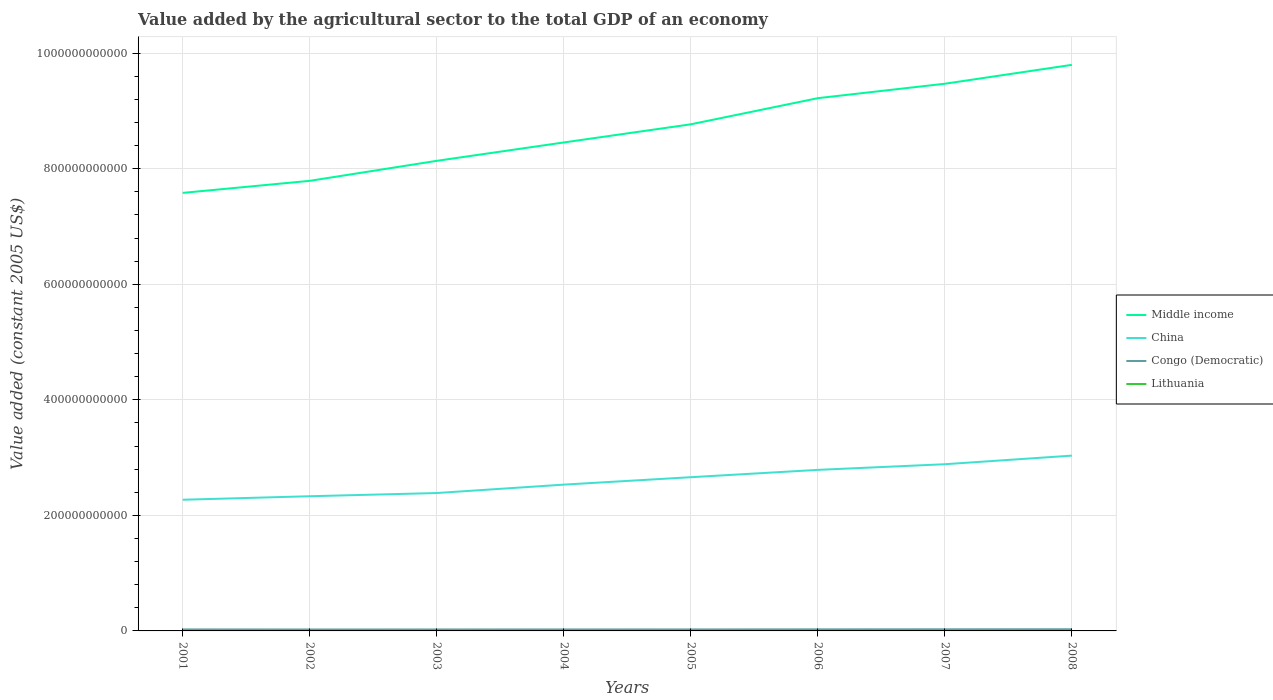Across all years, what is the maximum value added by the agricultural sector in Middle income?
Keep it short and to the point. 7.58e+11. What is the total value added by the agricultural sector in China in the graph?
Make the answer very short. -2.25e+1. What is the difference between the highest and the second highest value added by the agricultural sector in Congo (Democratic)?
Your response must be concise. 3.68e+08. Is the value added by the agricultural sector in Lithuania strictly greater than the value added by the agricultural sector in China over the years?
Give a very brief answer. Yes. What is the difference between two consecutive major ticks on the Y-axis?
Offer a terse response. 2.00e+11. Does the graph contain any zero values?
Ensure brevity in your answer.  No. Where does the legend appear in the graph?
Offer a very short reply. Center right. How are the legend labels stacked?
Offer a terse response. Vertical. What is the title of the graph?
Provide a succinct answer. Value added by the agricultural sector to the total GDP of an economy. Does "Lower middle income" appear as one of the legend labels in the graph?
Offer a terse response. No. What is the label or title of the X-axis?
Offer a terse response. Years. What is the label or title of the Y-axis?
Offer a very short reply. Value added (constant 2005 US$). What is the Value added (constant 2005 US$) of Middle income in 2001?
Your response must be concise. 7.58e+11. What is the Value added (constant 2005 US$) in China in 2001?
Offer a very short reply. 2.27e+11. What is the Value added (constant 2005 US$) of Congo (Democratic) in 2001?
Give a very brief answer. 2.61e+09. What is the Value added (constant 2005 US$) of Lithuania in 2001?
Provide a succinct answer. 1.03e+09. What is the Value added (constant 2005 US$) of Middle income in 2002?
Provide a succinct answer. 7.79e+11. What is the Value added (constant 2005 US$) of China in 2002?
Your response must be concise. 2.33e+11. What is the Value added (constant 2005 US$) in Congo (Democratic) in 2002?
Your response must be concise. 2.51e+09. What is the Value added (constant 2005 US$) of Lithuania in 2002?
Make the answer very short. 1.09e+09. What is the Value added (constant 2005 US$) in Middle income in 2003?
Give a very brief answer. 8.14e+11. What is the Value added (constant 2005 US$) in China in 2003?
Keep it short and to the point. 2.39e+11. What is the Value added (constant 2005 US$) of Congo (Democratic) in 2003?
Your response must be concise. 2.53e+09. What is the Value added (constant 2005 US$) of Lithuania in 2003?
Offer a very short reply. 1.15e+09. What is the Value added (constant 2005 US$) of Middle income in 2004?
Offer a very short reply. 8.46e+11. What is the Value added (constant 2005 US$) of China in 2004?
Ensure brevity in your answer.  2.53e+11. What is the Value added (constant 2005 US$) of Congo (Democratic) in 2004?
Keep it short and to the point. 2.57e+09. What is the Value added (constant 2005 US$) in Lithuania in 2004?
Ensure brevity in your answer.  1.11e+09. What is the Value added (constant 2005 US$) of Middle income in 2005?
Keep it short and to the point. 8.77e+11. What is the Value added (constant 2005 US$) in China in 2005?
Offer a terse response. 2.66e+11. What is the Value added (constant 2005 US$) of Congo (Democratic) in 2005?
Offer a very short reply. 2.58e+09. What is the Value added (constant 2005 US$) in Lithuania in 2005?
Provide a short and direct response. 1.13e+09. What is the Value added (constant 2005 US$) in Middle income in 2006?
Give a very brief answer. 9.22e+11. What is the Value added (constant 2005 US$) in China in 2006?
Ensure brevity in your answer.  2.79e+11. What is the Value added (constant 2005 US$) in Congo (Democratic) in 2006?
Keep it short and to the point. 2.73e+09. What is the Value added (constant 2005 US$) of Lithuania in 2006?
Keep it short and to the point. 1.01e+09. What is the Value added (constant 2005 US$) in Middle income in 2007?
Offer a very short reply. 9.47e+11. What is the Value added (constant 2005 US$) in China in 2007?
Offer a terse response. 2.89e+11. What is the Value added (constant 2005 US$) in Congo (Democratic) in 2007?
Ensure brevity in your answer.  2.80e+09. What is the Value added (constant 2005 US$) of Lithuania in 2007?
Ensure brevity in your answer.  1.13e+09. What is the Value added (constant 2005 US$) in Middle income in 2008?
Your answer should be very brief. 9.80e+11. What is the Value added (constant 2005 US$) of China in 2008?
Your answer should be very brief. 3.03e+11. What is the Value added (constant 2005 US$) in Congo (Democratic) in 2008?
Provide a short and direct response. 2.88e+09. What is the Value added (constant 2005 US$) of Lithuania in 2008?
Your answer should be compact. 1.16e+09. Across all years, what is the maximum Value added (constant 2005 US$) in Middle income?
Your answer should be very brief. 9.80e+11. Across all years, what is the maximum Value added (constant 2005 US$) in China?
Your answer should be very brief. 3.03e+11. Across all years, what is the maximum Value added (constant 2005 US$) of Congo (Democratic)?
Ensure brevity in your answer.  2.88e+09. Across all years, what is the maximum Value added (constant 2005 US$) of Lithuania?
Provide a short and direct response. 1.16e+09. Across all years, what is the minimum Value added (constant 2005 US$) of Middle income?
Offer a very short reply. 7.58e+11. Across all years, what is the minimum Value added (constant 2005 US$) of China?
Give a very brief answer. 2.27e+11. Across all years, what is the minimum Value added (constant 2005 US$) in Congo (Democratic)?
Your response must be concise. 2.51e+09. Across all years, what is the minimum Value added (constant 2005 US$) in Lithuania?
Offer a very short reply. 1.01e+09. What is the total Value added (constant 2005 US$) of Middle income in the graph?
Keep it short and to the point. 6.92e+12. What is the total Value added (constant 2005 US$) in China in the graph?
Provide a succinct answer. 2.09e+12. What is the total Value added (constant 2005 US$) of Congo (Democratic) in the graph?
Offer a very short reply. 2.12e+1. What is the total Value added (constant 2005 US$) in Lithuania in the graph?
Give a very brief answer. 8.80e+09. What is the difference between the Value added (constant 2005 US$) of Middle income in 2001 and that in 2002?
Provide a short and direct response. -2.08e+1. What is the difference between the Value added (constant 2005 US$) of China in 2001 and that in 2002?
Your answer should be very brief. -6.10e+09. What is the difference between the Value added (constant 2005 US$) of Congo (Democratic) in 2001 and that in 2002?
Your answer should be compact. 9.47e+07. What is the difference between the Value added (constant 2005 US$) of Lithuania in 2001 and that in 2002?
Offer a terse response. -6.32e+07. What is the difference between the Value added (constant 2005 US$) in Middle income in 2001 and that in 2003?
Provide a short and direct response. -5.55e+1. What is the difference between the Value added (constant 2005 US$) of China in 2001 and that in 2003?
Give a very brief answer. -1.16e+1. What is the difference between the Value added (constant 2005 US$) in Congo (Democratic) in 2001 and that in 2003?
Keep it short and to the point. 7.81e+07. What is the difference between the Value added (constant 2005 US$) in Lithuania in 2001 and that in 2003?
Your answer should be compact. -1.23e+08. What is the difference between the Value added (constant 2005 US$) of Middle income in 2001 and that in 2004?
Keep it short and to the point. -8.73e+1. What is the difference between the Value added (constant 2005 US$) of China in 2001 and that in 2004?
Your answer should be compact. -2.62e+1. What is the difference between the Value added (constant 2005 US$) of Congo (Democratic) in 2001 and that in 2004?
Your answer should be compact. 3.73e+07. What is the difference between the Value added (constant 2005 US$) in Lithuania in 2001 and that in 2004?
Offer a terse response. -8.31e+07. What is the difference between the Value added (constant 2005 US$) in Middle income in 2001 and that in 2005?
Your answer should be compact. -1.19e+11. What is the difference between the Value added (constant 2005 US$) of China in 2001 and that in 2005?
Give a very brief answer. -3.90e+1. What is the difference between the Value added (constant 2005 US$) in Congo (Democratic) in 2001 and that in 2005?
Give a very brief answer. 2.49e+07. What is the difference between the Value added (constant 2005 US$) in Lithuania in 2001 and that in 2005?
Ensure brevity in your answer.  -1.03e+08. What is the difference between the Value added (constant 2005 US$) of Middle income in 2001 and that in 2006?
Offer a terse response. -1.64e+11. What is the difference between the Value added (constant 2005 US$) in China in 2001 and that in 2006?
Your response must be concise. -5.17e+1. What is the difference between the Value added (constant 2005 US$) in Congo (Democratic) in 2001 and that in 2006?
Your answer should be very brief. -1.20e+08. What is the difference between the Value added (constant 2005 US$) of Lithuania in 2001 and that in 2006?
Offer a very short reply. 2.03e+07. What is the difference between the Value added (constant 2005 US$) of Middle income in 2001 and that in 2007?
Your answer should be very brief. -1.89e+11. What is the difference between the Value added (constant 2005 US$) of China in 2001 and that in 2007?
Make the answer very short. -6.15e+1. What is the difference between the Value added (constant 2005 US$) in Congo (Democratic) in 2001 and that in 2007?
Your response must be concise. -1.96e+08. What is the difference between the Value added (constant 2005 US$) in Lithuania in 2001 and that in 2007?
Give a very brief answer. -1.03e+08. What is the difference between the Value added (constant 2005 US$) of Middle income in 2001 and that in 2008?
Provide a short and direct response. -2.22e+11. What is the difference between the Value added (constant 2005 US$) of China in 2001 and that in 2008?
Offer a very short reply. -7.64e+1. What is the difference between the Value added (constant 2005 US$) of Congo (Democratic) in 2001 and that in 2008?
Offer a very short reply. -2.74e+08. What is the difference between the Value added (constant 2005 US$) of Lithuania in 2001 and that in 2008?
Offer a terse response. -1.31e+08. What is the difference between the Value added (constant 2005 US$) of Middle income in 2002 and that in 2003?
Your answer should be very brief. -3.46e+1. What is the difference between the Value added (constant 2005 US$) in China in 2002 and that in 2003?
Ensure brevity in your answer.  -5.54e+09. What is the difference between the Value added (constant 2005 US$) in Congo (Democratic) in 2002 and that in 2003?
Offer a very short reply. -1.67e+07. What is the difference between the Value added (constant 2005 US$) of Lithuania in 2002 and that in 2003?
Your answer should be compact. -5.97e+07. What is the difference between the Value added (constant 2005 US$) in Middle income in 2002 and that in 2004?
Your response must be concise. -6.64e+1. What is the difference between the Value added (constant 2005 US$) of China in 2002 and that in 2004?
Your answer should be compact. -2.01e+1. What is the difference between the Value added (constant 2005 US$) of Congo (Democratic) in 2002 and that in 2004?
Provide a succinct answer. -5.74e+07. What is the difference between the Value added (constant 2005 US$) of Lithuania in 2002 and that in 2004?
Provide a short and direct response. -1.99e+07. What is the difference between the Value added (constant 2005 US$) of Middle income in 2002 and that in 2005?
Provide a short and direct response. -9.79e+1. What is the difference between the Value added (constant 2005 US$) in China in 2002 and that in 2005?
Keep it short and to the point. -3.29e+1. What is the difference between the Value added (constant 2005 US$) in Congo (Democratic) in 2002 and that in 2005?
Offer a very short reply. -6.98e+07. What is the difference between the Value added (constant 2005 US$) in Lithuania in 2002 and that in 2005?
Your answer should be very brief. -3.94e+07. What is the difference between the Value added (constant 2005 US$) in Middle income in 2002 and that in 2006?
Your response must be concise. -1.43e+11. What is the difference between the Value added (constant 2005 US$) in China in 2002 and that in 2006?
Provide a short and direct response. -4.56e+1. What is the difference between the Value added (constant 2005 US$) in Congo (Democratic) in 2002 and that in 2006?
Offer a very short reply. -2.15e+08. What is the difference between the Value added (constant 2005 US$) of Lithuania in 2002 and that in 2006?
Your answer should be compact. 8.35e+07. What is the difference between the Value added (constant 2005 US$) in Middle income in 2002 and that in 2007?
Your answer should be very brief. -1.68e+11. What is the difference between the Value added (constant 2005 US$) of China in 2002 and that in 2007?
Your answer should be very brief. -5.54e+1. What is the difference between the Value added (constant 2005 US$) of Congo (Democratic) in 2002 and that in 2007?
Ensure brevity in your answer.  -2.91e+08. What is the difference between the Value added (constant 2005 US$) of Lithuania in 2002 and that in 2007?
Provide a short and direct response. -4.03e+07. What is the difference between the Value added (constant 2005 US$) of Middle income in 2002 and that in 2008?
Your response must be concise. -2.01e+11. What is the difference between the Value added (constant 2005 US$) of China in 2002 and that in 2008?
Provide a succinct answer. -7.03e+1. What is the difference between the Value added (constant 2005 US$) of Congo (Democratic) in 2002 and that in 2008?
Offer a terse response. -3.68e+08. What is the difference between the Value added (constant 2005 US$) in Lithuania in 2002 and that in 2008?
Give a very brief answer. -6.80e+07. What is the difference between the Value added (constant 2005 US$) in Middle income in 2003 and that in 2004?
Give a very brief answer. -3.18e+1. What is the difference between the Value added (constant 2005 US$) of China in 2003 and that in 2004?
Your answer should be compact. -1.45e+1. What is the difference between the Value added (constant 2005 US$) in Congo (Democratic) in 2003 and that in 2004?
Your response must be concise. -4.07e+07. What is the difference between the Value added (constant 2005 US$) in Lithuania in 2003 and that in 2004?
Keep it short and to the point. 3.98e+07. What is the difference between the Value added (constant 2005 US$) of Middle income in 2003 and that in 2005?
Give a very brief answer. -6.32e+1. What is the difference between the Value added (constant 2005 US$) in China in 2003 and that in 2005?
Your response must be concise. -2.74e+1. What is the difference between the Value added (constant 2005 US$) in Congo (Democratic) in 2003 and that in 2005?
Offer a terse response. -5.32e+07. What is the difference between the Value added (constant 2005 US$) in Lithuania in 2003 and that in 2005?
Offer a very short reply. 2.04e+07. What is the difference between the Value added (constant 2005 US$) of Middle income in 2003 and that in 2006?
Your response must be concise. -1.08e+11. What is the difference between the Value added (constant 2005 US$) in China in 2003 and that in 2006?
Provide a succinct answer. -4.01e+1. What is the difference between the Value added (constant 2005 US$) in Congo (Democratic) in 2003 and that in 2006?
Give a very brief answer. -1.99e+08. What is the difference between the Value added (constant 2005 US$) in Lithuania in 2003 and that in 2006?
Keep it short and to the point. 1.43e+08. What is the difference between the Value added (constant 2005 US$) of Middle income in 2003 and that in 2007?
Provide a short and direct response. -1.33e+11. What is the difference between the Value added (constant 2005 US$) of China in 2003 and that in 2007?
Ensure brevity in your answer.  -4.99e+1. What is the difference between the Value added (constant 2005 US$) of Congo (Democratic) in 2003 and that in 2007?
Provide a short and direct response. -2.74e+08. What is the difference between the Value added (constant 2005 US$) of Lithuania in 2003 and that in 2007?
Your answer should be compact. 1.95e+07. What is the difference between the Value added (constant 2005 US$) in Middle income in 2003 and that in 2008?
Make the answer very short. -1.66e+11. What is the difference between the Value added (constant 2005 US$) in China in 2003 and that in 2008?
Make the answer very short. -6.47e+1. What is the difference between the Value added (constant 2005 US$) in Congo (Democratic) in 2003 and that in 2008?
Offer a very short reply. -3.52e+08. What is the difference between the Value added (constant 2005 US$) in Lithuania in 2003 and that in 2008?
Keep it short and to the point. -8.30e+06. What is the difference between the Value added (constant 2005 US$) in Middle income in 2004 and that in 2005?
Ensure brevity in your answer.  -3.14e+1. What is the difference between the Value added (constant 2005 US$) of China in 2004 and that in 2005?
Provide a succinct answer. -1.29e+1. What is the difference between the Value added (constant 2005 US$) in Congo (Democratic) in 2004 and that in 2005?
Your answer should be very brief. -1.24e+07. What is the difference between the Value added (constant 2005 US$) of Lithuania in 2004 and that in 2005?
Offer a very short reply. -1.94e+07. What is the difference between the Value added (constant 2005 US$) of Middle income in 2004 and that in 2006?
Make the answer very short. -7.67e+1. What is the difference between the Value added (constant 2005 US$) of China in 2004 and that in 2006?
Your answer should be very brief. -2.55e+1. What is the difference between the Value added (constant 2005 US$) of Congo (Democratic) in 2004 and that in 2006?
Make the answer very short. -1.58e+08. What is the difference between the Value added (constant 2005 US$) of Lithuania in 2004 and that in 2006?
Ensure brevity in your answer.  1.03e+08. What is the difference between the Value added (constant 2005 US$) in Middle income in 2004 and that in 2007?
Ensure brevity in your answer.  -1.02e+11. What is the difference between the Value added (constant 2005 US$) of China in 2004 and that in 2007?
Your response must be concise. -3.53e+1. What is the difference between the Value added (constant 2005 US$) of Congo (Democratic) in 2004 and that in 2007?
Give a very brief answer. -2.33e+08. What is the difference between the Value added (constant 2005 US$) of Lithuania in 2004 and that in 2007?
Your answer should be compact. -2.04e+07. What is the difference between the Value added (constant 2005 US$) in Middle income in 2004 and that in 2008?
Offer a very short reply. -1.34e+11. What is the difference between the Value added (constant 2005 US$) of China in 2004 and that in 2008?
Your answer should be compact. -5.02e+1. What is the difference between the Value added (constant 2005 US$) of Congo (Democratic) in 2004 and that in 2008?
Make the answer very short. -3.11e+08. What is the difference between the Value added (constant 2005 US$) in Lithuania in 2004 and that in 2008?
Provide a short and direct response. -4.81e+07. What is the difference between the Value added (constant 2005 US$) in Middle income in 2005 and that in 2006?
Offer a terse response. -4.52e+1. What is the difference between the Value added (constant 2005 US$) in China in 2005 and that in 2006?
Give a very brief answer. -1.27e+1. What is the difference between the Value added (constant 2005 US$) of Congo (Democratic) in 2005 and that in 2006?
Offer a terse response. -1.45e+08. What is the difference between the Value added (constant 2005 US$) in Lithuania in 2005 and that in 2006?
Your response must be concise. 1.23e+08. What is the difference between the Value added (constant 2005 US$) of Middle income in 2005 and that in 2007?
Keep it short and to the point. -7.02e+1. What is the difference between the Value added (constant 2005 US$) of China in 2005 and that in 2007?
Give a very brief answer. -2.25e+1. What is the difference between the Value added (constant 2005 US$) of Congo (Democratic) in 2005 and that in 2007?
Offer a terse response. -2.21e+08. What is the difference between the Value added (constant 2005 US$) in Lithuania in 2005 and that in 2007?
Give a very brief answer. -9.14e+05. What is the difference between the Value added (constant 2005 US$) in Middle income in 2005 and that in 2008?
Your answer should be compact. -1.03e+11. What is the difference between the Value added (constant 2005 US$) of China in 2005 and that in 2008?
Your response must be concise. -3.73e+1. What is the difference between the Value added (constant 2005 US$) of Congo (Democratic) in 2005 and that in 2008?
Ensure brevity in your answer.  -2.99e+08. What is the difference between the Value added (constant 2005 US$) of Lithuania in 2005 and that in 2008?
Make the answer very short. -2.87e+07. What is the difference between the Value added (constant 2005 US$) in Middle income in 2006 and that in 2007?
Your answer should be compact. -2.50e+1. What is the difference between the Value added (constant 2005 US$) of China in 2006 and that in 2007?
Offer a very short reply. -9.80e+09. What is the difference between the Value added (constant 2005 US$) of Congo (Democratic) in 2006 and that in 2007?
Offer a very short reply. -7.55e+07. What is the difference between the Value added (constant 2005 US$) of Lithuania in 2006 and that in 2007?
Your answer should be very brief. -1.24e+08. What is the difference between the Value added (constant 2005 US$) of Middle income in 2006 and that in 2008?
Provide a succinct answer. -5.77e+1. What is the difference between the Value added (constant 2005 US$) in China in 2006 and that in 2008?
Your answer should be compact. -2.47e+1. What is the difference between the Value added (constant 2005 US$) of Congo (Democratic) in 2006 and that in 2008?
Keep it short and to the point. -1.53e+08. What is the difference between the Value added (constant 2005 US$) in Lithuania in 2006 and that in 2008?
Your answer should be compact. -1.52e+08. What is the difference between the Value added (constant 2005 US$) of Middle income in 2007 and that in 2008?
Give a very brief answer. -3.27e+1. What is the difference between the Value added (constant 2005 US$) of China in 2007 and that in 2008?
Your answer should be very brief. -1.49e+1. What is the difference between the Value added (constant 2005 US$) in Congo (Democratic) in 2007 and that in 2008?
Provide a succinct answer. -7.77e+07. What is the difference between the Value added (constant 2005 US$) in Lithuania in 2007 and that in 2008?
Offer a very short reply. -2.78e+07. What is the difference between the Value added (constant 2005 US$) of Middle income in 2001 and the Value added (constant 2005 US$) of China in 2002?
Your answer should be compact. 5.25e+11. What is the difference between the Value added (constant 2005 US$) in Middle income in 2001 and the Value added (constant 2005 US$) in Congo (Democratic) in 2002?
Keep it short and to the point. 7.56e+11. What is the difference between the Value added (constant 2005 US$) of Middle income in 2001 and the Value added (constant 2005 US$) of Lithuania in 2002?
Your answer should be very brief. 7.57e+11. What is the difference between the Value added (constant 2005 US$) in China in 2001 and the Value added (constant 2005 US$) in Congo (Democratic) in 2002?
Keep it short and to the point. 2.25e+11. What is the difference between the Value added (constant 2005 US$) in China in 2001 and the Value added (constant 2005 US$) in Lithuania in 2002?
Offer a very short reply. 2.26e+11. What is the difference between the Value added (constant 2005 US$) of Congo (Democratic) in 2001 and the Value added (constant 2005 US$) of Lithuania in 2002?
Provide a succinct answer. 1.52e+09. What is the difference between the Value added (constant 2005 US$) in Middle income in 2001 and the Value added (constant 2005 US$) in China in 2003?
Offer a terse response. 5.20e+11. What is the difference between the Value added (constant 2005 US$) in Middle income in 2001 and the Value added (constant 2005 US$) in Congo (Democratic) in 2003?
Offer a very short reply. 7.56e+11. What is the difference between the Value added (constant 2005 US$) of Middle income in 2001 and the Value added (constant 2005 US$) of Lithuania in 2003?
Give a very brief answer. 7.57e+11. What is the difference between the Value added (constant 2005 US$) in China in 2001 and the Value added (constant 2005 US$) in Congo (Democratic) in 2003?
Make the answer very short. 2.25e+11. What is the difference between the Value added (constant 2005 US$) in China in 2001 and the Value added (constant 2005 US$) in Lithuania in 2003?
Your answer should be very brief. 2.26e+11. What is the difference between the Value added (constant 2005 US$) in Congo (Democratic) in 2001 and the Value added (constant 2005 US$) in Lithuania in 2003?
Ensure brevity in your answer.  1.46e+09. What is the difference between the Value added (constant 2005 US$) in Middle income in 2001 and the Value added (constant 2005 US$) in China in 2004?
Ensure brevity in your answer.  5.05e+11. What is the difference between the Value added (constant 2005 US$) in Middle income in 2001 and the Value added (constant 2005 US$) in Congo (Democratic) in 2004?
Make the answer very short. 7.56e+11. What is the difference between the Value added (constant 2005 US$) in Middle income in 2001 and the Value added (constant 2005 US$) in Lithuania in 2004?
Offer a terse response. 7.57e+11. What is the difference between the Value added (constant 2005 US$) of China in 2001 and the Value added (constant 2005 US$) of Congo (Democratic) in 2004?
Ensure brevity in your answer.  2.24e+11. What is the difference between the Value added (constant 2005 US$) of China in 2001 and the Value added (constant 2005 US$) of Lithuania in 2004?
Ensure brevity in your answer.  2.26e+11. What is the difference between the Value added (constant 2005 US$) in Congo (Democratic) in 2001 and the Value added (constant 2005 US$) in Lithuania in 2004?
Make the answer very short. 1.50e+09. What is the difference between the Value added (constant 2005 US$) in Middle income in 2001 and the Value added (constant 2005 US$) in China in 2005?
Offer a very short reply. 4.92e+11. What is the difference between the Value added (constant 2005 US$) in Middle income in 2001 and the Value added (constant 2005 US$) in Congo (Democratic) in 2005?
Give a very brief answer. 7.56e+11. What is the difference between the Value added (constant 2005 US$) in Middle income in 2001 and the Value added (constant 2005 US$) in Lithuania in 2005?
Offer a terse response. 7.57e+11. What is the difference between the Value added (constant 2005 US$) in China in 2001 and the Value added (constant 2005 US$) in Congo (Democratic) in 2005?
Ensure brevity in your answer.  2.24e+11. What is the difference between the Value added (constant 2005 US$) of China in 2001 and the Value added (constant 2005 US$) of Lithuania in 2005?
Your response must be concise. 2.26e+11. What is the difference between the Value added (constant 2005 US$) in Congo (Democratic) in 2001 and the Value added (constant 2005 US$) in Lithuania in 2005?
Your answer should be very brief. 1.48e+09. What is the difference between the Value added (constant 2005 US$) in Middle income in 2001 and the Value added (constant 2005 US$) in China in 2006?
Provide a short and direct response. 4.79e+11. What is the difference between the Value added (constant 2005 US$) of Middle income in 2001 and the Value added (constant 2005 US$) of Congo (Democratic) in 2006?
Offer a terse response. 7.56e+11. What is the difference between the Value added (constant 2005 US$) of Middle income in 2001 and the Value added (constant 2005 US$) of Lithuania in 2006?
Offer a very short reply. 7.57e+11. What is the difference between the Value added (constant 2005 US$) in China in 2001 and the Value added (constant 2005 US$) in Congo (Democratic) in 2006?
Keep it short and to the point. 2.24e+11. What is the difference between the Value added (constant 2005 US$) of China in 2001 and the Value added (constant 2005 US$) of Lithuania in 2006?
Make the answer very short. 2.26e+11. What is the difference between the Value added (constant 2005 US$) of Congo (Democratic) in 2001 and the Value added (constant 2005 US$) of Lithuania in 2006?
Offer a terse response. 1.60e+09. What is the difference between the Value added (constant 2005 US$) in Middle income in 2001 and the Value added (constant 2005 US$) in China in 2007?
Give a very brief answer. 4.70e+11. What is the difference between the Value added (constant 2005 US$) in Middle income in 2001 and the Value added (constant 2005 US$) in Congo (Democratic) in 2007?
Your answer should be very brief. 7.55e+11. What is the difference between the Value added (constant 2005 US$) of Middle income in 2001 and the Value added (constant 2005 US$) of Lithuania in 2007?
Your response must be concise. 7.57e+11. What is the difference between the Value added (constant 2005 US$) in China in 2001 and the Value added (constant 2005 US$) in Congo (Democratic) in 2007?
Offer a very short reply. 2.24e+11. What is the difference between the Value added (constant 2005 US$) in China in 2001 and the Value added (constant 2005 US$) in Lithuania in 2007?
Your response must be concise. 2.26e+11. What is the difference between the Value added (constant 2005 US$) of Congo (Democratic) in 2001 and the Value added (constant 2005 US$) of Lithuania in 2007?
Make the answer very short. 1.48e+09. What is the difference between the Value added (constant 2005 US$) in Middle income in 2001 and the Value added (constant 2005 US$) in China in 2008?
Keep it short and to the point. 4.55e+11. What is the difference between the Value added (constant 2005 US$) in Middle income in 2001 and the Value added (constant 2005 US$) in Congo (Democratic) in 2008?
Provide a short and direct response. 7.55e+11. What is the difference between the Value added (constant 2005 US$) in Middle income in 2001 and the Value added (constant 2005 US$) in Lithuania in 2008?
Provide a short and direct response. 7.57e+11. What is the difference between the Value added (constant 2005 US$) in China in 2001 and the Value added (constant 2005 US$) in Congo (Democratic) in 2008?
Give a very brief answer. 2.24e+11. What is the difference between the Value added (constant 2005 US$) in China in 2001 and the Value added (constant 2005 US$) in Lithuania in 2008?
Offer a terse response. 2.26e+11. What is the difference between the Value added (constant 2005 US$) in Congo (Democratic) in 2001 and the Value added (constant 2005 US$) in Lithuania in 2008?
Offer a terse response. 1.45e+09. What is the difference between the Value added (constant 2005 US$) of Middle income in 2002 and the Value added (constant 2005 US$) of China in 2003?
Ensure brevity in your answer.  5.40e+11. What is the difference between the Value added (constant 2005 US$) in Middle income in 2002 and the Value added (constant 2005 US$) in Congo (Democratic) in 2003?
Your answer should be compact. 7.77e+11. What is the difference between the Value added (constant 2005 US$) of Middle income in 2002 and the Value added (constant 2005 US$) of Lithuania in 2003?
Offer a very short reply. 7.78e+11. What is the difference between the Value added (constant 2005 US$) in China in 2002 and the Value added (constant 2005 US$) in Congo (Democratic) in 2003?
Your response must be concise. 2.31e+11. What is the difference between the Value added (constant 2005 US$) in China in 2002 and the Value added (constant 2005 US$) in Lithuania in 2003?
Offer a very short reply. 2.32e+11. What is the difference between the Value added (constant 2005 US$) of Congo (Democratic) in 2002 and the Value added (constant 2005 US$) of Lithuania in 2003?
Ensure brevity in your answer.  1.36e+09. What is the difference between the Value added (constant 2005 US$) of Middle income in 2002 and the Value added (constant 2005 US$) of China in 2004?
Your answer should be compact. 5.26e+11. What is the difference between the Value added (constant 2005 US$) of Middle income in 2002 and the Value added (constant 2005 US$) of Congo (Democratic) in 2004?
Give a very brief answer. 7.77e+11. What is the difference between the Value added (constant 2005 US$) of Middle income in 2002 and the Value added (constant 2005 US$) of Lithuania in 2004?
Offer a terse response. 7.78e+11. What is the difference between the Value added (constant 2005 US$) in China in 2002 and the Value added (constant 2005 US$) in Congo (Democratic) in 2004?
Provide a succinct answer. 2.31e+11. What is the difference between the Value added (constant 2005 US$) of China in 2002 and the Value added (constant 2005 US$) of Lithuania in 2004?
Provide a short and direct response. 2.32e+11. What is the difference between the Value added (constant 2005 US$) in Congo (Democratic) in 2002 and the Value added (constant 2005 US$) in Lithuania in 2004?
Ensure brevity in your answer.  1.40e+09. What is the difference between the Value added (constant 2005 US$) in Middle income in 2002 and the Value added (constant 2005 US$) in China in 2005?
Ensure brevity in your answer.  5.13e+11. What is the difference between the Value added (constant 2005 US$) of Middle income in 2002 and the Value added (constant 2005 US$) of Congo (Democratic) in 2005?
Your answer should be compact. 7.76e+11. What is the difference between the Value added (constant 2005 US$) of Middle income in 2002 and the Value added (constant 2005 US$) of Lithuania in 2005?
Ensure brevity in your answer.  7.78e+11. What is the difference between the Value added (constant 2005 US$) of China in 2002 and the Value added (constant 2005 US$) of Congo (Democratic) in 2005?
Your response must be concise. 2.31e+11. What is the difference between the Value added (constant 2005 US$) of China in 2002 and the Value added (constant 2005 US$) of Lithuania in 2005?
Your answer should be compact. 2.32e+11. What is the difference between the Value added (constant 2005 US$) in Congo (Democratic) in 2002 and the Value added (constant 2005 US$) in Lithuania in 2005?
Offer a very short reply. 1.38e+09. What is the difference between the Value added (constant 2005 US$) in Middle income in 2002 and the Value added (constant 2005 US$) in China in 2006?
Keep it short and to the point. 5.00e+11. What is the difference between the Value added (constant 2005 US$) in Middle income in 2002 and the Value added (constant 2005 US$) in Congo (Democratic) in 2006?
Give a very brief answer. 7.76e+11. What is the difference between the Value added (constant 2005 US$) in Middle income in 2002 and the Value added (constant 2005 US$) in Lithuania in 2006?
Your response must be concise. 7.78e+11. What is the difference between the Value added (constant 2005 US$) of China in 2002 and the Value added (constant 2005 US$) of Congo (Democratic) in 2006?
Give a very brief answer. 2.30e+11. What is the difference between the Value added (constant 2005 US$) of China in 2002 and the Value added (constant 2005 US$) of Lithuania in 2006?
Provide a succinct answer. 2.32e+11. What is the difference between the Value added (constant 2005 US$) in Congo (Democratic) in 2002 and the Value added (constant 2005 US$) in Lithuania in 2006?
Provide a succinct answer. 1.51e+09. What is the difference between the Value added (constant 2005 US$) in Middle income in 2002 and the Value added (constant 2005 US$) in China in 2007?
Provide a short and direct response. 4.91e+11. What is the difference between the Value added (constant 2005 US$) in Middle income in 2002 and the Value added (constant 2005 US$) in Congo (Democratic) in 2007?
Your answer should be very brief. 7.76e+11. What is the difference between the Value added (constant 2005 US$) of Middle income in 2002 and the Value added (constant 2005 US$) of Lithuania in 2007?
Your response must be concise. 7.78e+11. What is the difference between the Value added (constant 2005 US$) of China in 2002 and the Value added (constant 2005 US$) of Congo (Democratic) in 2007?
Provide a succinct answer. 2.30e+11. What is the difference between the Value added (constant 2005 US$) in China in 2002 and the Value added (constant 2005 US$) in Lithuania in 2007?
Provide a succinct answer. 2.32e+11. What is the difference between the Value added (constant 2005 US$) in Congo (Democratic) in 2002 and the Value added (constant 2005 US$) in Lithuania in 2007?
Make the answer very short. 1.38e+09. What is the difference between the Value added (constant 2005 US$) in Middle income in 2002 and the Value added (constant 2005 US$) in China in 2008?
Keep it short and to the point. 4.76e+11. What is the difference between the Value added (constant 2005 US$) in Middle income in 2002 and the Value added (constant 2005 US$) in Congo (Democratic) in 2008?
Keep it short and to the point. 7.76e+11. What is the difference between the Value added (constant 2005 US$) in Middle income in 2002 and the Value added (constant 2005 US$) in Lithuania in 2008?
Ensure brevity in your answer.  7.78e+11. What is the difference between the Value added (constant 2005 US$) in China in 2002 and the Value added (constant 2005 US$) in Congo (Democratic) in 2008?
Provide a succinct answer. 2.30e+11. What is the difference between the Value added (constant 2005 US$) of China in 2002 and the Value added (constant 2005 US$) of Lithuania in 2008?
Your answer should be compact. 2.32e+11. What is the difference between the Value added (constant 2005 US$) in Congo (Democratic) in 2002 and the Value added (constant 2005 US$) in Lithuania in 2008?
Your answer should be very brief. 1.35e+09. What is the difference between the Value added (constant 2005 US$) of Middle income in 2003 and the Value added (constant 2005 US$) of China in 2004?
Make the answer very short. 5.60e+11. What is the difference between the Value added (constant 2005 US$) in Middle income in 2003 and the Value added (constant 2005 US$) in Congo (Democratic) in 2004?
Make the answer very short. 8.11e+11. What is the difference between the Value added (constant 2005 US$) in Middle income in 2003 and the Value added (constant 2005 US$) in Lithuania in 2004?
Give a very brief answer. 8.13e+11. What is the difference between the Value added (constant 2005 US$) in China in 2003 and the Value added (constant 2005 US$) in Congo (Democratic) in 2004?
Offer a terse response. 2.36e+11. What is the difference between the Value added (constant 2005 US$) in China in 2003 and the Value added (constant 2005 US$) in Lithuania in 2004?
Offer a terse response. 2.38e+11. What is the difference between the Value added (constant 2005 US$) of Congo (Democratic) in 2003 and the Value added (constant 2005 US$) of Lithuania in 2004?
Offer a very short reply. 1.42e+09. What is the difference between the Value added (constant 2005 US$) in Middle income in 2003 and the Value added (constant 2005 US$) in China in 2005?
Make the answer very short. 5.48e+11. What is the difference between the Value added (constant 2005 US$) of Middle income in 2003 and the Value added (constant 2005 US$) of Congo (Democratic) in 2005?
Keep it short and to the point. 8.11e+11. What is the difference between the Value added (constant 2005 US$) in Middle income in 2003 and the Value added (constant 2005 US$) in Lithuania in 2005?
Your answer should be compact. 8.13e+11. What is the difference between the Value added (constant 2005 US$) of China in 2003 and the Value added (constant 2005 US$) of Congo (Democratic) in 2005?
Your answer should be very brief. 2.36e+11. What is the difference between the Value added (constant 2005 US$) in China in 2003 and the Value added (constant 2005 US$) in Lithuania in 2005?
Provide a short and direct response. 2.38e+11. What is the difference between the Value added (constant 2005 US$) in Congo (Democratic) in 2003 and the Value added (constant 2005 US$) in Lithuania in 2005?
Offer a very short reply. 1.40e+09. What is the difference between the Value added (constant 2005 US$) of Middle income in 2003 and the Value added (constant 2005 US$) of China in 2006?
Your response must be concise. 5.35e+11. What is the difference between the Value added (constant 2005 US$) of Middle income in 2003 and the Value added (constant 2005 US$) of Congo (Democratic) in 2006?
Keep it short and to the point. 8.11e+11. What is the difference between the Value added (constant 2005 US$) in Middle income in 2003 and the Value added (constant 2005 US$) in Lithuania in 2006?
Your response must be concise. 8.13e+11. What is the difference between the Value added (constant 2005 US$) in China in 2003 and the Value added (constant 2005 US$) in Congo (Democratic) in 2006?
Your response must be concise. 2.36e+11. What is the difference between the Value added (constant 2005 US$) of China in 2003 and the Value added (constant 2005 US$) of Lithuania in 2006?
Offer a terse response. 2.38e+11. What is the difference between the Value added (constant 2005 US$) of Congo (Democratic) in 2003 and the Value added (constant 2005 US$) of Lithuania in 2006?
Provide a short and direct response. 1.52e+09. What is the difference between the Value added (constant 2005 US$) in Middle income in 2003 and the Value added (constant 2005 US$) in China in 2007?
Keep it short and to the point. 5.25e+11. What is the difference between the Value added (constant 2005 US$) of Middle income in 2003 and the Value added (constant 2005 US$) of Congo (Democratic) in 2007?
Keep it short and to the point. 8.11e+11. What is the difference between the Value added (constant 2005 US$) of Middle income in 2003 and the Value added (constant 2005 US$) of Lithuania in 2007?
Provide a short and direct response. 8.13e+11. What is the difference between the Value added (constant 2005 US$) of China in 2003 and the Value added (constant 2005 US$) of Congo (Democratic) in 2007?
Offer a very short reply. 2.36e+11. What is the difference between the Value added (constant 2005 US$) of China in 2003 and the Value added (constant 2005 US$) of Lithuania in 2007?
Provide a short and direct response. 2.38e+11. What is the difference between the Value added (constant 2005 US$) in Congo (Democratic) in 2003 and the Value added (constant 2005 US$) in Lithuania in 2007?
Offer a very short reply. 1.40e+09. What is the difference between the Value added (constant 2005 US$) in Middle income in 2003 and the Value added (constant 2005 US$) in China in 2008?
Provide a short and direct response. 5.10e+11. What is the difference between the Value added (constant 2005 US$) of Middle income in 2003 and the Value added (constant 2005 US$) of Congo (Democratic) in 2008?
Ensure brevity in your answer.  8.11e+11. What is the difference between the Value added (constant 2005 US$) in Middle income in 2003 and the Value added (constant 2005 US$) in Lithuania in 2008?
Offer a terse response. 8.13e+11. What is the difference between the Value added (constant 2005 US$) in China in 2003 and the Value added (constant 2005 US$) in Congo (Democratic) in 2008?
Make the answer very short. 2.36e+11. What is the difference between the Value added (constant 2005 US$) in China in 2003 and the Value added (constant 2005 US$) in Lithuania in 2008?
Ensure brevity in your answer.  2.38e+11. What is the difference between the Value added (constant 2005 US$) in Congo (Democratic) in 2003 and the Value added (constant 2005 US$) in Lithuania in 2008?
Ensure brevity in your answer.  1.37e+09. What is the difference between the Value added (constant 2005 US$) of Middle income in 2004 and the Value added (constant 2005 US$) of China in 2005?
Keep it short and to the point. 5.79e+11. What is the difference between the Value added (constant 2005 US$) in Middle income in 2004 and the Value added (constant 2005 US$) in Congo (Democratic) in 2005?
Your answer should be very brief. 8.43e+11. What is the difference between the Value added (constant 2005 US$) in Middle income in 2004 and the Value added (constant 2005 US$) in Lithuania in 2005?
Offer a very short reply. 8.44e+11. What is the difference between the Value added (constant 2005 US$) in China in 2004 and the Value added (constant 2005 US$) in Congo (Democratic) in 2005?
Your answer should be very brief. 2.51e+11. What is the difference between the Value added (constant 2005 US$) in China in 2004 and the Value added (constant 2005 US$) in Lithuania in 2005?
Provide a succinct answer. 2.52e+11. What is the difference between the Value added (constant 2005 US$) in Congo (Democratic) in 2004 and the Value added (constant 2005 US$) in Lithuania in 2005?
Offer a terse response. 1.44e+09. What is the difference between the Value added (constant 2005 US$) of Middle income in 2004 and the Value added (constant 2005 US$) of China in 2006?
Ensure brevity in your answer.  5.67e+11. What is the difference between the Value added (constant 2005 US$) of Middle income in 2004 and the Value added (constant 2005 US$) of Congo (Democratic) in 2006?
Your answer should be very brief. 8.43e+11. What is the difference between the Value added (constant 2005 US$) of Middle income in 2004 and the Value added (constant 2005 US$) of Lithuania in 2006?
Ensure brevity in your answer.  8.45e+11. What is the difference between the Value added (constant 2005 US$) of China in 2004 and the Value added (constant 2005 US$) of Congo (Democratic) in 2006?
Your answer should be very brief. 2.51e+11. What is the difference between the Value added (constant 2005 US$) of China in 2004 and the Value added (constant 2005 US$) of Lithuania in 2006?
Your response must be concise. 2.52e+11. What is the difference between the Value added (constant 2005 US$) of Congo (Democratic) in 2004 and the Value added (constant 2005 US$) of Lithuania in 2006?
Your response must be concise. 1.56e+09. What is the difference between the Value added (constant 2005 US$) in Middle income in 2004 and the Value added (constant 2005 US$) in China in 2007?
Keep it short and to the point. 5.57e+11. What is the difference between the Value added (constant 2005 US$) of Middle income in 2004 and the Value added (constant 2005 US$) of Congo (Democratic) in 2007?
Your answer should be compact. 8.43e+11. What is the difference between the Value added (constant 2005 US$) of Middle income in 2004 and the Value added (constant 2005 US$) of Lithuania in 2007?
Give a very brief answer. 8.44e+11. What is the difference between the Value added (constant 2005 US$) of China in 2004 and the Value added (constant 2005 US$) of Congo (Democratic) in 2007?
Your answer should be very brief. 2.50e+11. What is the difference between the Value added (constant 2005 US$) of China in 2004 and the Value added (constant 2005 US$) of Lithuania in 2007?
Ensure brevity in your answer.  2.52e+11. What is the difference between the Value added (constant 2005 US$) of Congo (Democratic) in 2004 and the Value added (constant 2005 US$) of Lithuania in 2007?
Give a very brief answer. 1.44e+09. What is the difference between the Value added (constant 2005 US$) in Middle income in 2004 and the Value added (constant 2005 US$) in China in 2008?
Provide a succinct answer. 5.42e+11. What is the difference between the Value added (constant 2005 US$) of Middle income in 2004 and the Value added (constant 2005 US$) of Congo (Democratic) in 2008?
Your answer should be compact. 8.43e+11. What is the difference between the Value added (constant 2005 US$) in Middle income in 2004 and the Value added (constant 2005 US$) in Lithuania in 2008?
Offer a terse response. 8.44e+11. What is the difference between the Value added (constant 2005 US$) of China in 2004 and the Value added (constant 2005 US$) of Congo (Democratic) in 2008?
Provide a succinct answer. 2.50e+11. What is the difference between the Value added (constant 2005 US$) of China in 2004 and the Value added (constant 2005 US$) of Lithuania in 2008?
Give a very brief answer. 2.52e+11. What is the difference between the Value added (constant 2005 US$) of Congo (Democratic) in 2004 and the Value added (constant 2005 US$) of Lithuania in 2008?
Make the answer very short. 1.41e+09. What is the difference between the Value added (constant 2005 US$) of Middle income in 2005 and the Value added (constant 2005 US$) of China in 2006?
Give a very brief answer. 5.98e+11. What is the difference between the Value added (constant 2005 US$) of Middle income in 2005 and the Value added (constant 2005 US$) of Congo (Democratic) in 2006?
Your response must be concise. 8.74e+11. What is the difference between the Value added (constant 2005 US$) of Middle income in 2005 and the Value added (constant 2005 US$) of Lithuania in 2006?
Your answer should be very brief. 8.76e+11. What is the difference between the Value added (constant 2005 US$) in China in 2005 and the Value added (constant 2005 US$) in Congo (Democratic) in 2006?
Ensure brevity in your answer.  2.63e+11. What is the difference between the Value added (constant 2005 US$) of China in 2005 and the Value added (constant 2005 US$) of Lithuania in 2006?
Ensure brevity in your answer.  2.65e+11. What is the difference between the Value added (constant 2005 US$) in Congo (Democratic) in 2005 and the Value added (constant 2005 US$) in Lithuania in 2006?
Give a very brief answer. 1.58e+09. What is the difference between the Value added (constant 2005 US$) of Middle income in 2005 and the Value added (constant 2005 US$) of China in 2007?
Provide a succinct answer. 5.88e+11. What is the difference between the Value added (constant 2005 US$) of Middle income in 2005 and the Value added (constant 2005 US$) of Congo (Democratic) in 2007?
Make the answer very short. 8.74e+11. What is the difference between the Value added (constant 2005 US$) in Middle income in 2005 and the Value added (constant 2005 US$) in Lithuania in 2007?
Offer a terse response. 8.76e+11. What is the difference between the Value added (constant 2005 US$) in China in 2005 and the Value added (constant 2005 US$) in Congo (Democratic) in 2007?
Your response must be concise. 2.63e+11. What is the difference between the Value added (constant 2005 US$) in China in 2005 and the Value added (constant 2005 US$) in Lithuania in 2007?
Make the answer very short. 2.65e+11. What is the difference between the Value added (constant 2005 US$) in Congo (Democratic) in 2005 and the Value added (constant 2005 US$) in Lithuania in 2007?
Give a very brief answer. 1.45e+09. What is the difference between the Value added (constant 2005 US$) in Middle income in 2005 and the Value added (constant 2005 US$) in China in 2008?
Provide a short and direct response. 5.74e+11. What is the difference between the Value added (constant 2005 US$) in Middle income in 2005 and the Value added (constant 2005 US$) in Congo (Democratic) in 2008?
Offer a very short reply. 8.74e+11. What is the difference between the Value added (constant 2005 US$) in Middle income in 2005 and the Value added (constant 2005 US$) in Lithuania in 2008?
Your answer should be compact. 8.76e+11. What is the difference between the Value added (constant 2005 US$) of China in 2005 and the Value added (constant 2005 US$) of Congo (Democratic) in 2008?
Give a very brief answer. 2.63e+11. What is the difference between the Value added (constant 2005 US$) in China in 2005 and the Value added (constant 2005 US$) in Lithuania in 2008?
Provide a short and direct response. 2.65e+11. What is the difference between the Value added (constant 2005 US$) of Congo (Democratic) in 2005 and the Value added (constant 2005 US$) of Lithuania in 2008?
Your response must be concise. 1.42e+09. What is the difference between the Value added (constant 2005 US$) of Middle income in 2006 and the Value added (constant 2005 US$) of China in 2007?
Your response must be concise. 6.34e+11. What is the difference between the Value added (constant 2005 US$) in Middle income in 2006 and the Value added (constant 2005 US$) in Congo (Democratic) in 2007?
Ensure brevity in your answer.  9.19e+11. What is the difference between the Value added (constant 2005 US$) of Middle income in 2006 and the Value added (constant 2005 US$) of Lithuania in 2007?
Provide a short and direct response. 9.21e+11. What is the difference between the Value added (constant 2005 US$) in China in 2006 and the Value added (constant 2005 US$) in Congo (Democratic) in 2007?
Give a very brief answer. 2.76e+11. What is the difference between the Value added (constant 2005 US$) in China in 2006 and the Value added (constant 2005 US$) in Lithuania in 2007?
Provide a short and direct response. 2.78e+11. What is the difference between the Value added (constant 2005 US$) of Congo (Democratic) in 2006 and the Value added (constant 2005 US$) of Lithuania in 2007?
Give a very brief answer. 1.60e+09. What is the difference between the Value added (constant 2005 US$) in Middle income in 2006 and the Value added (constant 2005 US$) in China in 2008?
Keep it short and to the point. 6.19e+11. What is the difference between the Value added (constant 2005 US$) of Middle income in 2006 and the Value added (constant 2005 US$) of Congo (Democratic) in 2008?
Give a very brief answer. 9.19e+11. What is the difference between the Value added (constant 2005 US$) of Middle income in 2006 and the Value added (constant 2005 US$) of Lithuania in 2008?
Your answer should be compact. 9.21e+11. What is the difference between the Value added (constant 2005 US$) in China in 2006 and the Value added (constant 2005 US$) in Congo (Democratic) in 2008?
Ensure brevity in your answer.  2.76e+11. What is the difference between the Value added (constant 2005 US$) of China in 2006 and the Value added (constant 2005 US$) of Lithuania in 2008?
Your response must be concise. 2.78e+11. What is the difference between the Value added (constant 2005 US$) in Congo (Democratic) in 2006 and the Value added (constant 2005 US$) in Lithuania in 2008?
Your answer should be very brief. 1.57e+09. What is the difference between the Value added (constant 2005 US$) in Middle income in 2007 and the Value added (constant 2005 US$) in China in 2008?
Keep it short and to the point. 6.44e+11. What is the difference between the Value added (constant 2005 US$) of Middle income in 2007 and the Value added (constant 2005 US$) of Congo (Democratic) in 2008?
Make the answer very short. 9.44e+11. What is the difference between the Value added (constant 2005 US$) of Middle income in 2007 and the Value added (constant 2005 US$) of Lithuania in 2008?
Your answer should be very brief. 9.46e+11. What is the difference between the Value added (constant 2005 US$) of China in 2007 and the Value added (constant 2005 US$) of Congo (Democratic) in 2008?
Offer a very short reply. 2.86e+11. What is the difference between the Value added (constant 2005 US$) in China in 2007 and the Value added (constant 2005 US$) in Lithuania in 2008?
Your response must be concise. 2.87e+11. What is the difference between the Value added (constant 2005 US$) in Congo (Democratic) in 2007 and the Value added (constant 2005 US$) in Lithuania in 2008?
Offer a terse response. 1.64e+09. What is the average Value added (constant 2005 US$) in Middle income per year?
Your answer should be very brief. 8.65e+11. What is the average Value added (constant 2005 US$) in China per year?
Provide a short and direct response. 2.61e+11. What is the average Value added (constant 2005 US$) in Congo (Democratic) per year?
Ensure brevity in your answer.  2.65e+09. What is the average Value added (constant 2005 US$) in Lithuania per year?
Ensure brevity in your answer.  1.10e+09. In the year 2001, what is the difference between the Value added (constant 2005 US$) of Middle income and Value added (constant 2005 US$) of China?
Offer a very short reply. 5.31e+11. In the year 2001, what is the difference between the Value added (constant 2005 US$) of Middle income and Value added (constant 2005 US$) of Congo (Democratic)?
Provide a short and direct response. 7.56e+11. In the year 2001, what is the difference between the Value added (constant 2005 US$) of Middle income and Value added (constant 2005 US$) of Lithuania?
Keep it short and to the point. 7.57e+11. In the year 2001, what is the difference between the Value added (constant 2005 US$) in China and Value added (constant 2005 US$) in Congo (Democratic)?
Your answer should be compact. 2.24e+11. In the year 2001, what is the difference between the Value added (constant 2005 US$) in China and Value added (constant 2005 US$) in Lithuania?
Your response must be concise. 2.26e+11. In the year 2001, what is the difference between the Value added (constant 2005 US$) in Congo (Democratic) and Value added (constant 2005 US$) in Lithuania?
Give a very brief answer. 1.58e+09. In the year 2002, what is the difference between the Value added (constant 2005 US$) in Middle income and Value added (constant 2005 US$) in China?
Give a very brief answer. 5.46e+11. In the year 2002, what is the difference between the Value added (constant 2005 US$) in Middle income and Value added (constant 2005 US$) in Congo (Democratic)?
Provide a succinct answer. 7.77e+11. In the year 2002, what is the difference between the Value added (constant 2005 US$) of Middle income and Value added (constant 2005 US$) of Lithuania?
Keep it short and to the point. 7.78e+11. In the year 2002, what is the difference between the Value added (constant 2005 US$) of China and Value added (constant 2005 US$) of Congo (Democratic)?
Provide a short and direct response. 2.31e+11. In the year 2002, what is the difference between the Value added (constant 2005 US$) of China and Value added (constant 2005 US$) of Lithuania?
Offer a terse response. 2.32e+11. In the year 2002, what is the difference between the Value added (constant 2005 US$) of Congo (Democratic) and Value added (constant 2005 US$) of Lithuania?
Ensure brevity in your answer.  1.42e+09. In the year 2003, what is the difference between the Value added (constant 2005 US$) of Middle income and Value added (constant 2005 US$) of China?
Ensure brevity in your answer.  5.75e+11. In the year 2003, what is the difference between the Value added (constant 2005 US$) of Middle income and Value added (constant 2005 US$) of Congo (Democratic)?
Provide a short and direct response. 8.11e+11. In the year 2003, what is the difference between the Value added (constant 2005 US$) in Middle income and Value added (constant 2005 US$) in Lithuania?
Your response must be concise. 8.13e+11. In the year 2003, what is the difference between the Value added (constant 2005 US$) in China and Value added (constant 2005 US$) in Congo (Democratic)?
Provide a succinct answer. 2.36e+11. In the year 2003, what is the difference between the Value added (constant 2005 US$) of China and Value added (constant 2005 US$) of Lithuania?
Your answer should be very brief. 2.38e+11. In the year 2003, what is the difference between the Value added (constant 2005 US$) in Congo (Democratic) and Value added (constant 2005 US$) in Lithuania?
Provide a short and direct response. 1.38e+09. In the year 2004, what is the difference between the Value added (constant 2005 US$) of Middle income and Value added (constant 2005 US$) of China?
Provide a succinct answer. 5.92e+11. In the year 2004, what is the difference between the Value added (constant 2005 US$) in Middle income and Value added (constant 2005 US$) in Congo (Democratic)?
Give a very brief answer. 8.43e+11. In the year 2004, what is the difference between the Value added (constant 2005 US$) of Middle income and Value added (constant 2005 US$) of Lithuania?
Provide a short and direct response. 8.44e+11. In the year 2004, what is the difference between the Value added (constant 2005 US$) in China and Value added (constant 2005 US$) in Congo (Democratic)?
Offer a very short reply. 2.51e+11. In the year 2004, what is the difference between the Value added (constant 2005 US$) in China and Value added (constant 2005 US$) in Lithuania?
Provide a short and direct response. 2.52e+11. In the year 2004, what is the difference between the Value added (constant 2005 US$) in Congo (Democratic) and Value added (constant 2005 US$) in Lithuania?
Make the answer very short. 1.46e+09. In the year 2005, what is the difference between the Value added (constant 2005 US$) in Middle income and Value added (constant 2005 US$) in China?
Provide a short and direct response. 6.11e+11. In the year 2005, what is the difference between the Value added (constant 2005 US$) of Middle income and Value added (constant 2005 US$) of Congo (Democratic)?
Your answer should be compact. 8.74e+11. In the year 2005, what is the difference between the Value added (constant 2005 US$) of Middle income and Value added (constant 2005 US$) of Lithuania?
Provide a short and direct response. 8.76e+11. In the year 2005, what is the difference between the Value added (constant 2005 US$) in China and Value added (constant 2005 US$) in Congo (Democratic)?
Your response must be concise. 2.63e+11. In the year 2005, what is the difference between the Value added (constant 2005 US$) of China and Value added (constant 2005 US$) of Lithuania?
Keep it short and to the point. 2.65e+11. In the year 2005, what is the difference between the Value added (constant 2005 US$) of Congo (Democratic) and Value added (constant 2005 US$) of Lithuania?
Make the answer very short. 1.45e+09. In the year 2006, what is the difference between the Value added (constant 2005 US$) in Middle income and Value added (constant 2005 US$) in China?
Offer a very short reply. 6.43e+11. In the year 2006, what is the difference between the Value added (constant 2005 US$) of Middle income and Value added (constant 2005 US$) of Congo (Democratic)?
Offer a terse response. 9.19e+11. In the year 2006, what is the difference between the Value added (constant 2005 US$) in Middle income and Value added (constant 2005 US$) in Lithuania?
Provide a short and direct response. 9.21e+11. In the year 2006, what is the difference between the Value added (constant 2005 US$) in China and Value added (constant 2005 US$) in Congo (Democratic)?
Offer a very short reply. 2.76e+11. In the year 2006, what is the difference between the Value added (constant 2005 US$) of China and Value added (constant 2005 US$) of Lithuania?
Your response must be concise. 2.78e+11. In the year 2006, what is the difference between the Value added (constant 2005 US$) in Congo (Democratic) and Value added (constant 2005 US$) in Lithuania?
Provide a short and direct response. 1.72e+09. In the year 2007, what is the difference between the Value added (constant 2005 US$) in Middle income and Value added (constant 2005 US$) in China?
Your response must be concise. 6.59e+11. In the year 2007, what is the difference between the Value added (constant 2005 US$) in Middle income and Value added (constant 2005 US$) in Congo (Democratic)?
Provide a succinct answer. 9.44e+11. In the year 2007, what is the difference between the Value added (constant 2005 US$) of Middle income and Value added (constant 2005 US$) of Lithuania?
Your answer should be very brief. 9.46e+11. In the year 2007, what is the difference between the Value added (constant 2005 US$) in China and Value added (constant 2005 US$) in Congo (Democratic)?
Provide a succinct answer. 2.86e+11. In the year 2007, what is the difference between the Value added (constant 2005 US$) in China and Value added (constant 2005 US$) in Lithuania?
Your answer should be very brief. 2.87e+11. In the year 2007, what is the difference between the Value added (constant 2005 US$) of Congo (Democratic) and Value added (constant 2005 US$) of Lithuania?
Give a very brief answer. 1.67e+09. In the year 2008, what is the difference between the Value added (constant 2005 US$) in Middle income and Value added (constant 2005 US$) in China?
Provide a short and direct response. 6.76e+11. In the year 2008, what is the difference between the Value added (constant 2005 US$) in Middle income and Value added (constant 2005 US$) in Congo (Democratic)?
Offer a very short reply. 9.77e+11. In the year 2008, what is the difference between the Value added (constant 2005 US$) of Middle income and Value added (constant 2005 US$) of Lithuania?
Provide a short and direct response. 9.79e+11. In the year 2008, what is the difference between the Value added (constant 2005 US$) in China and Value added (constant 2005 US$) in Congo (Democratic)?
Your answer should be very brief. 3.01e+11. In the year 2008, what is the difference between the Value added (constant 2005 US$) of China and Value added (constant 2005 US$) of Lithuania?
Keep it short and to the point. 3.02e+11. In the year 2008, what is the difference between the Value added (constant 2005 US$) in Congo (Democratic) and Value added (constant 2005 US$) in Lithuania?
Make the answer very short. 1.72e+09. What is the ratio of the Value added (constant 2005 US$) in Middle income in 2001 to that in 2002?
Your answer should be compact. 0.97. What is the ratio of the Value added (constant 2005 US$) in China in 2001 to that in 2002?
Make the answer very short. 0.97. What is the ratio of the Value added (constant 2005 US$) in Congo (Democratic) in 2001 to that in 2002?
Your response must be concise. 1.04. What is the ratio of the Value added (constant 2005 US$) in Lithuania in 2001 to that in 2002?
Provide a short and direct response. 0.94. What is the ratio of the Value added (constant 2005 US$) in Middle income in 2001 to that in 2003?
Keep it short and to the point. 0.93. What is the ratio of the Value added (constant 2005 US$) in China in 2001 to that in 2003?
Provide a short and direct response. 0.95. What is the ratio of the Value added (constant 2005 US$) in Congo (Democratic) in 2001 to that in 2003?
Offer a terse response. 1.03. What is the ratio of the Value added (constant 2005 US$) of Lithuania in 2001 to that in 2003?
Give a very brief answer. 0.89. What is the ratio of the Value added (constant 2005 US$) in Middle income in 2001 to that in 2004?
Keep it short and to the point. 0.9. What is the ratio of the Value added (constant 2005 US$) of China in 2001 to that in 2004?
Your response must be concise. 0.9. What is the ratio of the Value added (constant 2005 US$) of Congo (Democratic) in 2001 to that in 2004?
Your response must be concise. 1.01. What is the ratio of the Value added (constant 2005 US$) of Lithuania in 2001 to that in 2004?
Ensure brevity in your answer.  0.93. What is the ratio of the Value added (constant 2005 US$) of Middle income in 2001 to that in 2005?
Make the answer very short. 0.86. What is the ratio of the Value added (constant 2005 US$) in China in 2001 to that in 2005?
Give a very brief answer. 0.85. What is the ratio of the Value added (constant 2005 US$) in Congo (Democratic) in 2001 to that in 2005?
Give a very brief answer. 1.01. What is the ratio of the Value added (constant 2005 US$) in Lithuania in 2001 to that in 2005?
Offer a very short reply. 0.91. What is the ratio of the Value added (constant 2005 US$) in Middle income in 2001 to that in 2006?
Keep it short and to the point. 0.82. What is the ratio of the Value added (constant 2005 US$) of China in 2001 to that in 2006?
Ensure brevity in your answer.  0.81. What is the ratio of the Value added (constant 2005 US$) of Congo (Democratic) in 2001 to that in 2006?
Give a very brief answer. 0.96. What is the ratio of the Value added (constant 2005 US$) of Lithuania in 2001 to that in 2006?
Provide a succinct answer. 1.02. What is the ratio of the Value added (constant 2005 US$) in Middle income in 2001 to that in 2007?
Your response must be concise. 0.8. What is the ratio of the Value added (constant 2005 US$) in China in 2001 to that in 2007?
Your answer should be compact. 0.79. What is the ratio of the Value added (constant 2005 US$) of Congo (Democratic) in 2001 to that in 2007?
Your answer should be very brief. 0.93. What is the ratio of the Value added (constant 2005 US$) in Lithuania in 2001 to that in 2007?
Your answer should be very brief. 0.91. What is the ratio of the Value added (constant 2005 US$) of Middle income in 2001 to that in 2008?
Provide a short and direct response. 0.77. What is the ratio of the Value added (constant 2005 US$) of China in 2001 to that in 2008?
Offer a terse response. 0.75. What is the ratio of the Value added (constant 2005 US$) in Congo (Democratic) in 2001 to that in 2008?
Keep it short and to the point. 0.91. What is the ratio of the Value added (constant 2005 US$) of Lithuania in 2001 to that in 2008?
Ensure brevity in your answer.  0.89. What is the ratio of the Value added (constant 2005 US$) in Middle income in 2002 to that in 2003?
Keep it short and to the point. 0.96. What is the ratio of the Value added (constant 2005 US$) of China in 2002 to that in 2003?
Keep it short and to the point. 0.98. What is the ratio of the Value added (constant 2005 US$) in Congo (Democratic) in 2002 to that in 2003?
Your answer should be very brief. 0.99. What is the ratio of the Value added (constant 2005 US$) of Lithuania in 2002 to that in 2003?
Offer a terse response. 0.95. What is the ratio of the Value added (constant 2005 US$) of Middle income in 2002 to that in 2004?
Keep it short and to the point. 0.92. What is the ratio of the Value added (constant 2005 US$) of China in 2002 to that in 2004?
Keep it short and to the point. 0.92. What is the ratio of the Value added (constant 2005 US$) in Congo (Democratic) in 2002 to that in 2004?
Provide a succinct answer. 0.98. What is the ratio of the Value added (constant 2005 US$) of Lithuania in 2002 to that in 2004?
Your answer should be very brief. 0.98. What is the ratio of the Value added (constant 2005 US$) of Middle income in 2002 to that in 2005?
Provide a succinct answer. 0.89. What is the ratio of the Value added (constant 2005 US$) of China in 2002 to that in 2005?
Your answer should be very brief. 0.88. What is the ratio of the Value added (constant 2005 US$) of Congo (Democratic) in 2002 to that in 2005?
Ensure brevity in your answer.  0.97. What is the ratio of the Value added (constant 2005 US$) in Lithuania in 2002 to that in 2005?
Provide a succinct answer. 0.97. What is the ratio of the Value added (constant 2005 US$) of Middle income in 2002 to that in 2006?
Offer a terse response. 0.84. What is the ratio of the Value added (constant 2005 US$) of China in 2002 to that in 2006?
Provide a short and direct response. 0.84. What is the ratio of the Value added (constant 2005 US$) of Congo (Democratic) in 2002 to that in 2006?
Make the answer very short. 0.92. What is the ratio of the Value added (constant 2005 US$) in Lithuania in 2002 to that in 2006?
Ensure brevity in your answer.  1.08. What is the ratio of the Value added (constant 2005 US$) of Middle income in 2002 to that in 2007?
Offer a very short reply. 0.82. What is the ratio of the Value added (constant 2005 US$) in China in 2002 to that in 2007?
Ensure brevity in your answer.  0.81. What is the ratio of the Value added (constant 2005 US$) of Congo (Democratic) in 2002 to that in 2007?
Make the answer very short. 0.9. What is the ratio of the Value added (constant 2005 US$) of Lithuania in 2002 to that in 2007?
Keep it short and to the point. 0.96. What is the ratio of the Value added (constant 2005 US$) in Middle income in 2002 to that in 2008?
Provide a succinct answer. 0.8. What is the ratio of the Value added (constant 2005 US$) in China in 2002 to that in 2008?
Your answer should be compact. 0.77. What is the ratio of the Value added (constant 2005 US$) in Congo (Democratic) in 2002 to that in 2008?
Offer a very short reply. 0.87. What is the ratio of the Value added (constant 2005 US$) of Lithuania in 2002 to that in 2008?
Your answer should be compact. 0.94. What is the ratio of the Value added (constant 2005 US$) in Middle income in 2003 to that in 2004?
Ensure brevity in your answer.  0.96. What is the ratio of the Value added (constant 2005 US$) of China in 2003 to that in 2004?
Your answer should be very brief. 0.94. What is the ratio of the Value added (constant 2005 US$) of Congo (Democratic) in 2003 to that in 2004?
Offer a terse response. 0.98. What is the ratio of the Value added (constant 2005 US$) of Lithuania in 2003 to that in 2004?
Give a very brief answer. 1.04. What is the ratio of the Value added (constant 2005 US$) in Middle income in 2003 to that in 2005?
Ensure brevity in your answer.  0.93. What is the ratio of the Value added (constant 2005 US$) of China in 2003 to that in 2005?
Give a very brief answer. 0.9. What is the ratio of the Value added (constant 2005 US$) of Congo (Democratic) in 2003 to that in 2005?
Your response must be concise. 0.98. What is the ratio of the Value added (constant 2005 US$) in Middle income in 2003 to that in 2006?
Give a very brief answer. 0.88. What is the ratio of the Value added (constant 2005 US$) of China in 2003 to that in 2006?
Offer a very short reply. 0.86. What is the ratio of the Value added (constant 2005 US$) of Congo (Democratic) in 2003 to that in 2006?
Offer a terse response. 0.93. What is the ratio of the Value added (constant 2005 US$) in Lithuania in 2003 to that in 2006?
Your answer should be compact. 1.14. What is the ratio of the Value added (constant 2005 US$) of Middle income in 2003 to that in 2007?
Provide a short and direct response. 0.86. What is the ratio of the Value added (constant 2005 US$) in China in 2003 to that in 2007?
Provide a short and direct response. 0.83. What is the ratio of the Value added (constant 2005 US$) of Congo (Democratic) in 2003 to that in 2007?
Provide a succinct answer. 0.9. What is the ratio of the Value added (constant 2005 US$) of Lithuania in 2003 to that in 2007?
Your answer should be very brief. 1.02. What is the ratio of the Value added (constant 2005 US$) of Middle income in 2003 to that in 2008?
Keep it short and to the point. 0.83. What is the ratio of the Value added (constant 2005 US$) of China in 2003 to that in 2008?
Offer a terse response. 0.79. What is the ratio of the Value added (constant 2005 US$) in Congo (Democratic) in 2003 to that in 2008?
Make the answer very short. 0.88. What is the ratio of the Value added (constant 2005 US$) in Middle income in 2004 to that in 2005?
Make the answer very short. 0.96. What is the ratio of the Value added (constant 2005 US$) in China in 2004 to that in 2005?
Offer a very short reply. 0.95. What is the ratio of the Value added (constant 2005 US$) of Lithuania in 2004 to that in 2005?
Keep it short and to the point. 0.98. What is the ratio of the Value added (constant 2005 US$) of Middle income in 2004 to that in 2006?
Provide a short and direct response. 0.92. What is the ratio of the Value added (constant 2005 US$) of China in 2004 to that in 2006?
Provide a short and direct response. 0.91. What is the ratio of the Value added (constant 2005 US$) of Congo (Democratic) in 2004 to that in 2006?
Your response must be concise. 0.94. What is the ratio of the Value added (constant 2005 US$) in Lithuania in 2004 to that in 2006?
Offer a very short reply. 1.1. What is the ratio of the Value added (constant 2005 US$) in Middle income in 2004 to that in 2007?
Give a very brief answer. 0.89. What is the ratio of the Value added (constant 2005 US$) of China in 2004 to that in 2007?
Keep it short and to the point. 0.88. What is the ratio of the Value added (constant 2005 US$) in Congo (Democratic) in 2004 to that in 2007?
Your answer should be very brief. 0.92. What is the ratio of the Value added (constant 2005 US$) of Middle income in 2004 to that in 2008?
Offer a terse response. 0.86. What is the ratio of the Value added (constant 2005 US$) of China in 2004 to that in 2008?
Your response must be concise. 0.83. What is the ratio of the Value added (constant 2005 US$) of Congo (Democratic) in 2004 to that in 2008?
Your answer should be very brief. 0.89. What is the ratio of the Value added (constant 2005 US$) of Lithuania in 2004 to that in 2008?
Keep it short and to the point. 0.96. What is the ratio of the Value added (constant 2005 US$) in Middle income in 2005 to that in 2006?
Your answer should be very brief. 0.95. What is the ratio of the Value added (constant 2005 US$) of China in 2005 to that in 2006?
Offer a terse response. 0.95. What is the ratio of the Value added (constant 2005 US$) of Congo (Democratic) in 2005 to that in 2006?
Provide a succinct answer. 0.95. What is the ratio of the Value added (constant 2005 US$) in Lithuania in 2005 to that in 2006?
Offer a terse response. 1.12. What is the ratio of the Value added (constant 2005 US$) in Middle income in 2005 to that in 2007?
Keep it short and to the point. 0.93. What is the ratio of the Value added (constant 2005 US$) of China in 2005 to that in 2007?
Keep it short and to the point. 0.92. What is the ratio of the Value added (constant 2005 US$) of Congo (Democratic) in 2005 to that in 2007?
Your response must be concise. 0.92. What is the ratio of the Value added (constant 2005 US$) in Middle income in 2005 to that in 2008?
Provide a short and direct response. 0.9. What is the ratio of the Value added (constant 2005 US$) in China in 2005 to that in 2008?
Offer a terse response. 0.88. What is the ratio of the Value added (constant 2005 US$) of Congo (Democratic) in 2005 to that in 2008?
Provide a short and direct response. 0.9. What is the ratio of the Value added (constant 2005 US$) in Lithuania in 2005 to that in 2008?
Make the answer very short. 0.98. What is the ratio of the Value added (constant 2005 US$) in Middle income in 2006 to that in 2007?
Your answer should be very brief. 0.97. What is the ratio of the Value added (constant 2005 US$) in Lithuania in 2006 to that in 2007?
Your response must be concise. 0.89. What is the ratio of the Value added (constant 2005 US$) of Middle income in 2006 to that in 2008?
Your response must be concise. 0.94. What is the ratio of the Value added (constant 2005 US$) in China in 2006 to that in 2008?
Your answer should be compact. 0.92. What is the ratio of the Value added (constant 2005 US$) in Congo (Democratic) in 2006 to that in 2008?
Give a very brief answer. 0.95. What is the ratio of the Value added (constant 2005 US$) of Lithuania in 2006 to that in 2008?
Your answer should be compact. 0.87. What is the ratio of the Value added (constant 2005 US$) of Middle income in 2007 to that in 2008?
Give a very brief answer. 0.97. What is the ratio of the Value added (constant 2005 US$) of China in 2007 to that in 2008?
Your answer should be very brief. 0.95. What is the difference between the highest and the second highest Value added (constant 2005 US$) of Middle income?
Your response must be concise. 3.27e+1. What is the difference between the highest and the second highest Value added (constant 2005 US$) of China?
Give a very brief answer. 1.49e+1. What is the difference between the highest and the second highest Value added (constant 2005 US$) in Congo (Democratic)?
Your response must be concise. 7.77e+07. What is the difference between the highest and the second highest Value added (constant 2005 US$) in Lithuania?
Your response must be concise. 8.30e+06. What is the difference between the highest and the lowest Value added (constant 2005 US$) in Middle income?
Provide a short and direct response. 2.22e+11. What is the difference between the highest and the lowest Value added (constant 2005 US$) in China?
Ensure brevity in your answer.  7.64e+1. What is the difference between the highest and the lowest Value added (constant 2005 US$) of Congo (Democratic)?
Your answer should be compact. 3.68e+08. What is the difference between the highest and the lowest Value added (constant 2005 US$) in Lithuania?
Make the answer very short. 1.52e+08. 